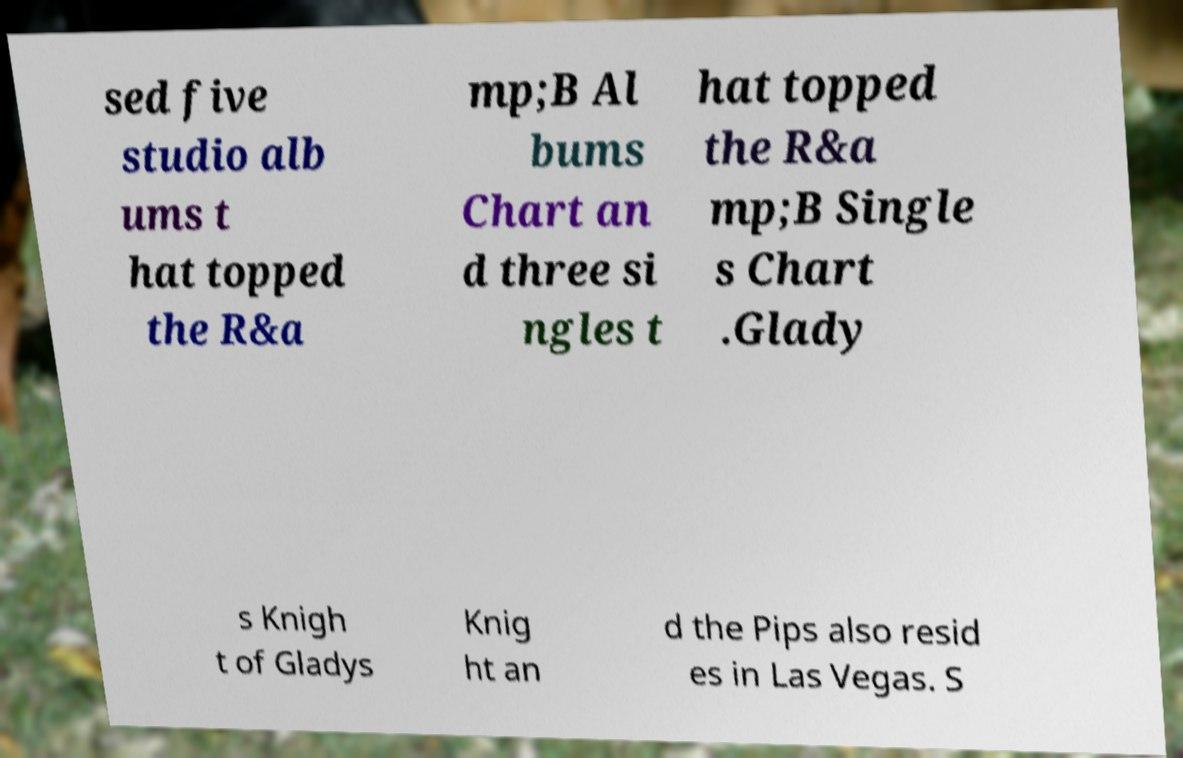Could you extract and type out the text from this image? sed five studio alb ums t hat topped the R&a mp;B Al bums Chart an d three si ngles t hat topped the R&a mp;B Single s Chart .Glady s Knigh t of Gladys Knig ht an d the Pips also resid es in Las Vegas. S 